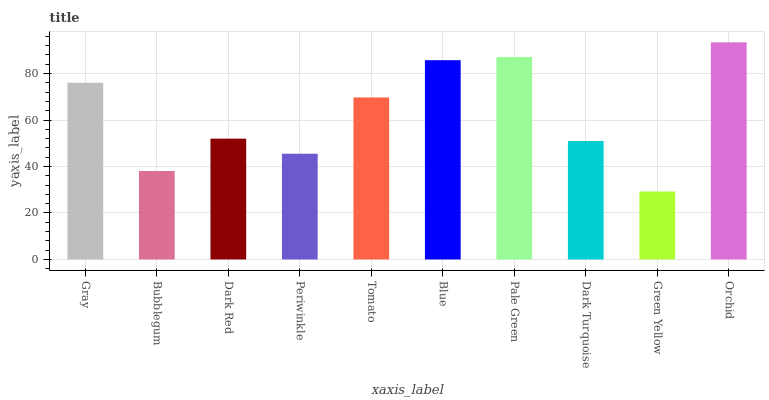Is Bubblegum the minimum?
Answer yes or no. No. Is Bubblegum the maximum?
Answer yes or no. No. Is Gray greater than Bubblegum?
Answer yes or no. Yes. Is Bubblegum less than Gray?
Answer yes or no. Yes. Is Bubblegum greater than Gray?
Answer yes or no. No. Is Gray less than Bubblegum?
Answer yes or no. No. Is Tomato the high median?
Answer yes or no. Yes. Is Dark Red the low median?
Answer yes or no. Yes. Is Gray the high median?
Answer yes or no. No. Is Periwinkle the low median?
Answer yes or no. No. 